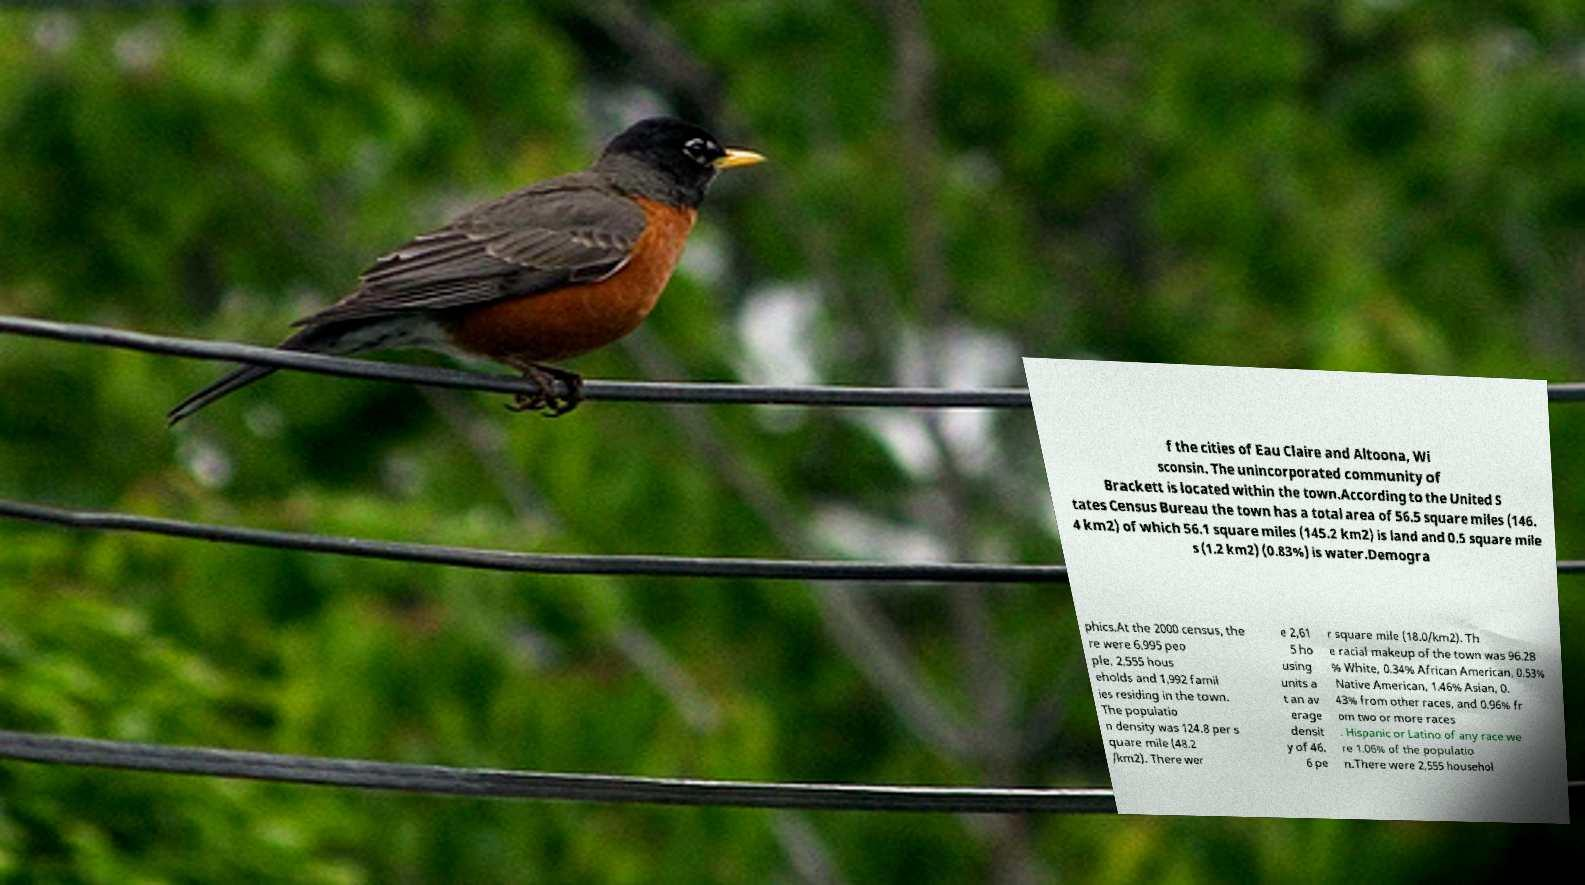Please identify and transcribe the text found in this image. f the cities of Eau Claire and Altoona, Wi sconsin. The unincorporated community of Brackett is located within the town.According to the United S tates Census Bureau the town has a total area of 56.5 square miles (146. 4 km2) of which 56.1 square miles (145.2 km2) is land and 0.5 square mile s (1.2 km2) (0.83%) is water.Demogra phics.At the 2000 census, the re were 6,995 peo ple, 2,555 hous eholds and 1,992 famil ies residing in the town. The populatio n density was 124.8 per s quare mile (48.2 /km2). There wer e 2,61 5 ho using units a t an av erage densit y of 46. 6 pe r square mile (18.0/km2). Th e racial makeup of the town was 96.28 % White, 0.34% African American, 0.53% Native American, 1.46% Asian, 0. 43% from other races, and 0.96% fr om two or more races . Hispanic or Latino of any race we re 1.06% of the populatio n.There were 2,555 househol 